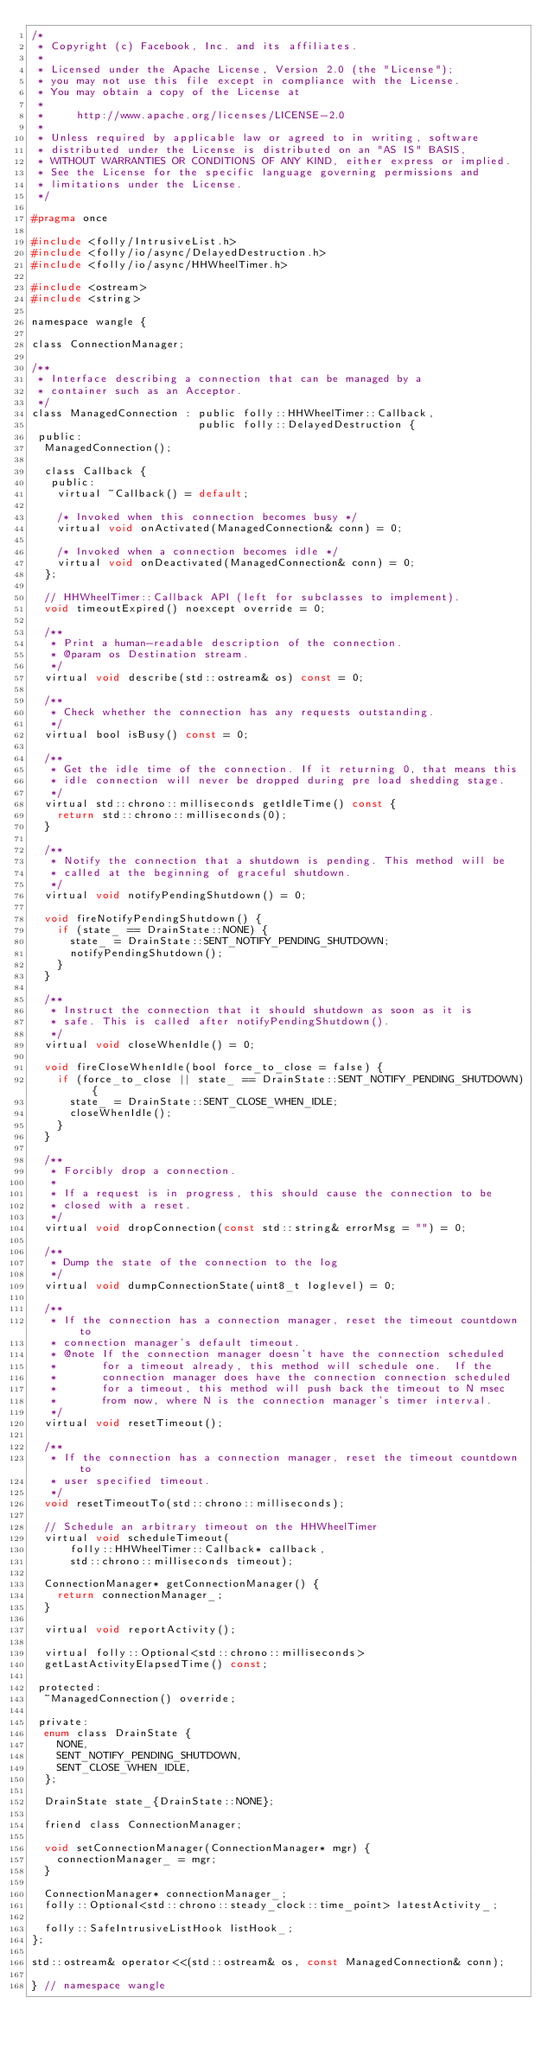Convert code to text. <code><loc_0><loc_0><loc_500><loc_500><_C_>/*
 * Copyright (c) Facebook, Inc. and its affiliates.
 *
 * Licensed under the Apache License, Version 2.0 (the "License");
 * you may not use this file except in compliance with the License.
 * You may obtain a copy of the License at
 *
 *     http://www.apache.org/licenses/LICENSE-2.0
 *
 * Unless required by applicable law or agreed to in writing, software
 * distributed under the License is distributed on an "AS IS" BASIS,
 * WITHOUT WARRANTIES OR CONDITIONS OF ANY KIND, either express or implied.
 * See the License for the specific language governing permissions and
 * limitations under the License.
 */

#pragma once

#include <folly/IntrusiveList.h>
#include <folly/io/async/DelayedDestruction.h>
#include <folly/io/async/HHWheelTimer.h>

#include <ostream>
#include <string>

namespace wangle {

class ConnectionManager;

/**
 * Interface describing a connection that can be managed by a
 * container such as an Acceptor.
 */
class ManagedConnection : public folly::HHWheelTimer::Callback,
                          public folly::DelayedDestruction {
 public:
  ManagedConnection();

  class Callback {
   public:
    virtual ~Callback() = default;

    /* Invoked when this connection becomes busy */
    virtual void onActivated(ManagedConnection& conn) = 0;

    /* Invoked when a connection becomes idle */
    virtual void onDeactivated(ManagedConnection& conn) = 0;
  };

  // HHWheelTimer::Callback API (left for subclasses to implement).
  void timeoutExpired() noexcept override = 0;

  /**
   * Print a human-readable description of the connection.
   * @param os Destination stream.
   */
  virtual void describe(std::ostream& os) const = 0;

  /**
   * Check whether the connection has any requests outstanding.
   */
  virtual bool isBusy() const = 0;

  /**
   * Get the idle time of the connection. If it returning 0, that means this
   * idle connection will never be dropped during pre load shedding stage.
   */
  virtual std::chrono::milliseconds getIdleTime() const {
    return std::chrono::milliseconds(0);
  }

  /**
   * Notify the connection that a shutdown is pending. This method will be
   * called at the beginning of graceful shutdown.
   */
  virtual void notifyPendingShutdown() = 0;

  void fireNotifyPendingShutdown() {
    if (state_ == DrainState::NONE) {
      state_ = DrainState::SENT_NOTIFY_PENDING_SHUTDOWN;
      notifyPendingShutdown();
    }
  }

  /**
   * Instruct the connection that it should shutdown as soon as it is
   * safe. This is called after notifyPendingShutdown().
   */
  virtual void closeWhenIdle() = 0;

  void fireCloseWhenIdle(bool force_to_close = false) {
    if (force_to_close || state_ == DrainState::SENT_NOTIFY_PENDING_SHUTDOWN) {
      state_ = DrainState::SENT_CLOSE_WHEN_IDLE;
      closeWhenIdle();
    }
  }

  /**
   * Forcibly drop a connection.
   *
   * If a request is in progress, this should cause the connection to be
   * closed with a reset.
   */
  virtual void dropConnection(const std::string& errorMsg = "") = 0;

  /**
   * Dump the state of the connection to the log
   */
  virtual void dumpConnectionState(uint8_t loglevel) = 0;

  /**
   * If the connection has a connection manager, reset the timeout countdown to
   * connection manager's default timeout.
   * @note If the connection manager doesn't have the connection scheduled
   *       for a timeout already, this method will schedule one.  If the
   *       connection manager does have the connection connection scheduled
   *       for a timeout, this method will push back the timeout to N msec
   *       from now, where N is the connection manager's timer interval.
   */
  virtual void resetTimeout();

  /**
   * If the connection has a connection manager, reset the timeout countdown to
   * user specified timeout.
   */
  void resetTimeoutTo(std::chrono::milliseconds);

  // Schedule an arbitrary timeout on the HHWheelTimer
  virtual void scheduleTimeout(
      folly::HHWheelTimer::Callback* callback,
      std::chrono::milliseconds timeout);

  ConnectionManager* getConnectionManager() {
    return connectionManager_;
  }

  virtual void reportActivity();

  virtual folly::Optional<std::chrono::milliseconds>
  getLastActivityElapsedTime() const;

 protected:
  ~ManagedConnection() override;

 private:
  enum class DrainState {
    NONE,
    SENT_NOTIFY_PENDING_SHUTDOWN,
    SENT_CLOSE_WHEN_IDLE,
  };

  DrainState state_{DrainState::NONE};

  friend class ConnectionManager;

  void setConnectionManager(ConnectionManager* mgr) {
    connectionManager_ = mgr;
  }

  ConnectionManager* connectionManager_;
  folly::Optional<std::chrono::steady_clock::time_point> latestActivity_;

  folly::SafeIntrusiveListHook listHook_;
};

std::ostream& operator<<(std::ostream& os, const ManagedConnection& conn);

} // namespace wangle
</code> 